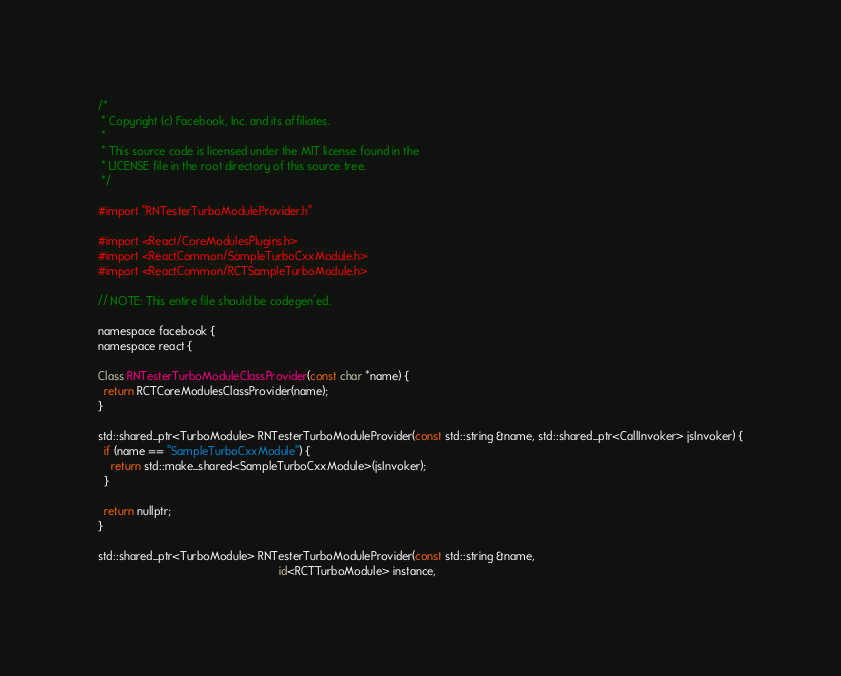Convert code to text. <code><loc_0><loc_0><loc_500><loc_500><_ObjectiveC_>/*
 * Copyright (c) Facebook, Inc. and its affiliates.
 *
 * This source code is licensed under the MIT license found in the
 * LICENSE file in the root directory of this source tree.
 */

#import "RNTesterTurboModuleProvider.h"

#import <React/CoreModulesPlugins.h>
#import <ReactCommon/SampleTurboCxxModule.h>
#import <ReactCommon/RCTSampleTurboModule.h>

// NOTE: This entire file should be codegen'ed.

namespace facebook {
namespace react {

Class RNTesterTurboModuleClassProvider(const char *name) {
  return RCTCoreModulesClassProvider(name);
}

std::shared_ptr<TurboModule> RNTesterTurboModuleProvider(const std::string &name, std::shared_ptr<CallInvoker> jsInvoker) {
  if (name == "SampleTurboCxxModule") {
    return std::make_shared<SampleTurboCxxModule>(jsInvoker);
  }

  return nullptr;
}

std::shared_ptr<TurboModule> RNTesterTurboModuleProvider(const std::string &name,
                                                         id<RCTTurboModule> instance,</code> 